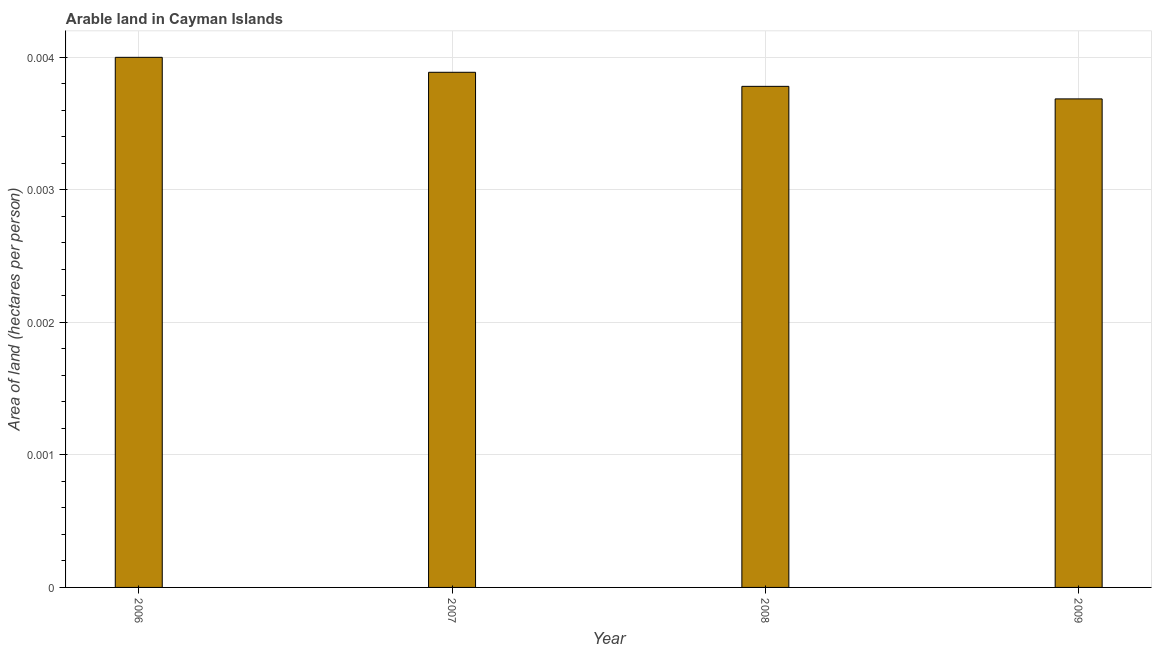Does the graph contain any zero values?
Ensure brevity in your answer.  No. What is the title of the graph?
Ensure brevity in your answer.  Arable land in Cayman Islands. What is the label or title of the Y-axis?
Offer a terse response. Area of land (hectares per person). What is the area of arable land in 2009?
Provide a succinct answer. 0. Across all years, what is the maximum area of arable land?
Your answer should be compact. 0. Across all years, what is the minimum area of arable land?
Your answer should be compact. 0. What is the sum of the area of arable land?
Keep it short and to the point. 0.02. What is the difference between the area of arable land in 2008 and 2009?
Offer a very short reply. 0. What is the average area of arable land per year?
Your response must be concise. 0. What is the median area of arable land?
Your answer should be very brief. 0. Do a majority of the years between 2009 and 2006 (inclusive) have area of arable land greater than 0.0002 hectares per person?
Give a very brief answer. Yes. What is the ratio of the area of arable land in 2006 to that in 2007?
Give a very brief answer. 1.03. What is the difference between the highest and the second highest area of arable land?
Keep it short and to the point. 0. Is the sum of the area of arable land in 2007 and 2008 greater than the maximum area of arable land across all years?
Your response must be concise. Yes. How many bars are there?
Your answer should be very brief. 4. What is the difference between two consecutive major ticks on the Y-axis?
Your answer should be compact. 0. What is the Area of land (hectares per person) in 2006?
Your answer should be compact. 0. What is the Area of land (hectares per person) of 2007?
Make the answer very short. 0. What is the Area of land (hectares per person) in 2008?
Keep it short and to the point. 0. What is the Area of land (hectares per person) in 2009?
Make the answer very short. 0. What is the difference between the Area of land (hectares per person) in 2006 and 2007?
Your answer should be compact. 0. What is the difference between the Area of land (hectares per person) in 2006 and 2008?
Make the answer very short. 0. What is the difference between the Area of land (hectares per person) in 2006 and 2009?
Your answer should be very brief. 0. What is the difference between the Area of land (hectares per person) in 2007 and 2008?
Offer a terse response. 0. What is the difference between the Area of land (hectares per person) in 2008 and 2009?
Your answer should be very brief. 9e-5. What is the ratio of the Area of land (hectares per person) in 2006 to that in 2008?
Make the answer very short. 1.06. What is the ratio of the Area of land (hectares per person) in 2006 to that in 2009?
Offer a very short reply. 1.08. What is the ratio of the Area of land (hectares per person) in 2007 to that in 2008?
Provide a succinct answer. 1.03. What is the ratio of the Area of land (hectares per person) in 2007 to that in 2009?
Your answer should be compact. 1.05. What is the ratio of the Area of land (hectares per person) in 2008 to that in 2009?
Provide a short and direct response. 1.03. 